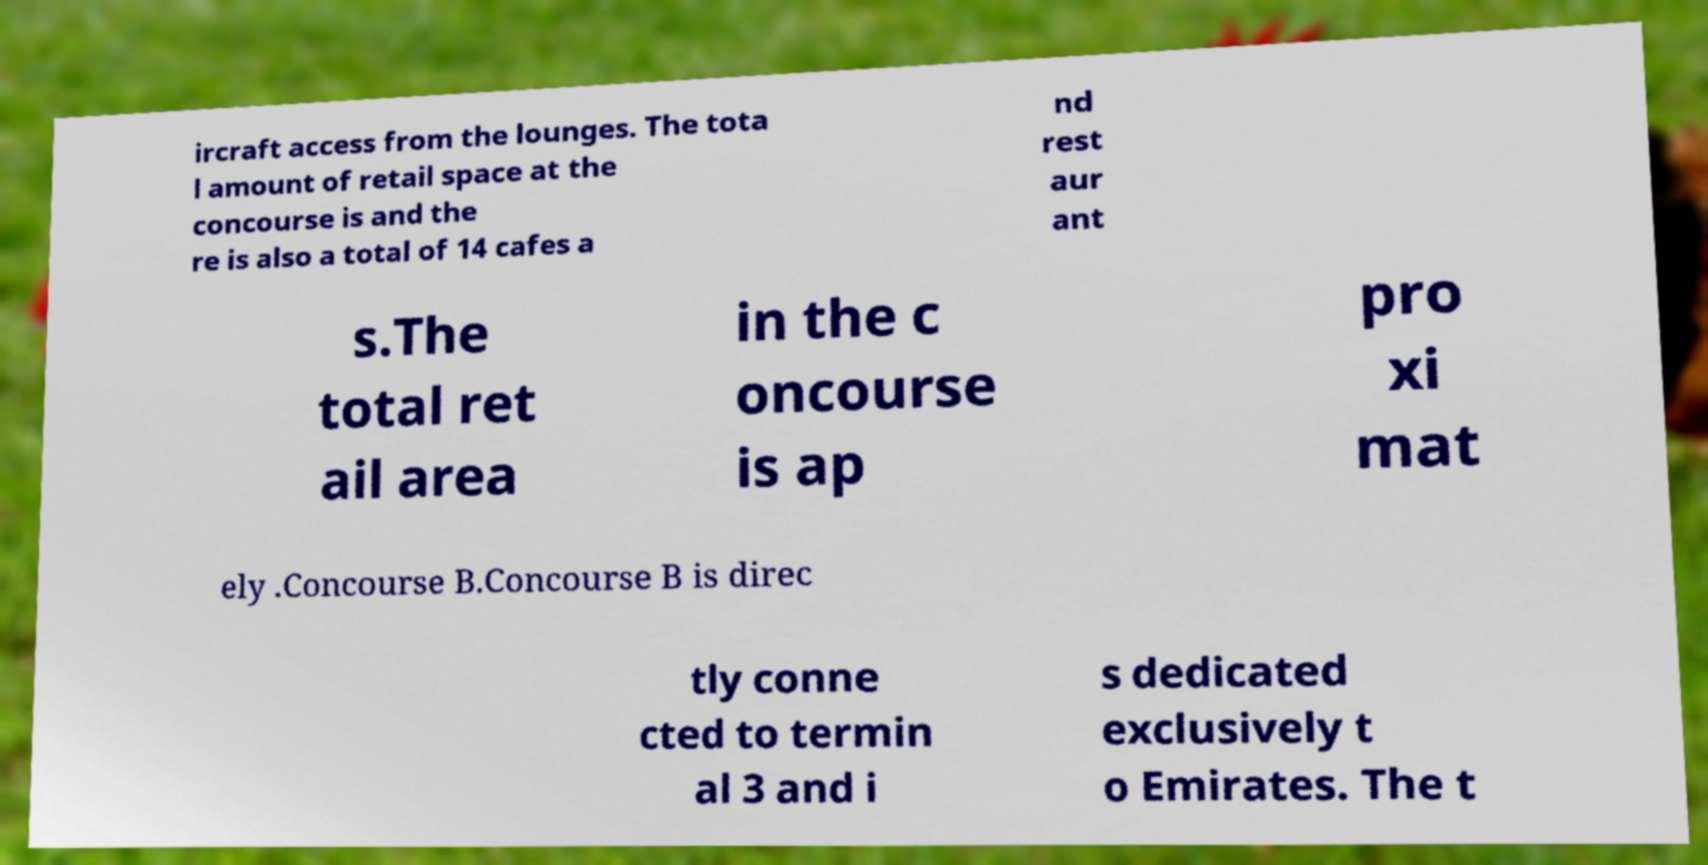Could you assist in decoding the text presented in this image and type it out clearly? ircraft access from the lounges. The tota l amount of retail space at the concourse is and the re is also a total of 14 cafes a nd rest aur ant s.The total ret ail area in the c oncourse is ap pro xi mat ely .Concourse B.Concourse B is direc tly conne cted to termin al 3 and i s dedicated exclusively t o Emirates. The t 